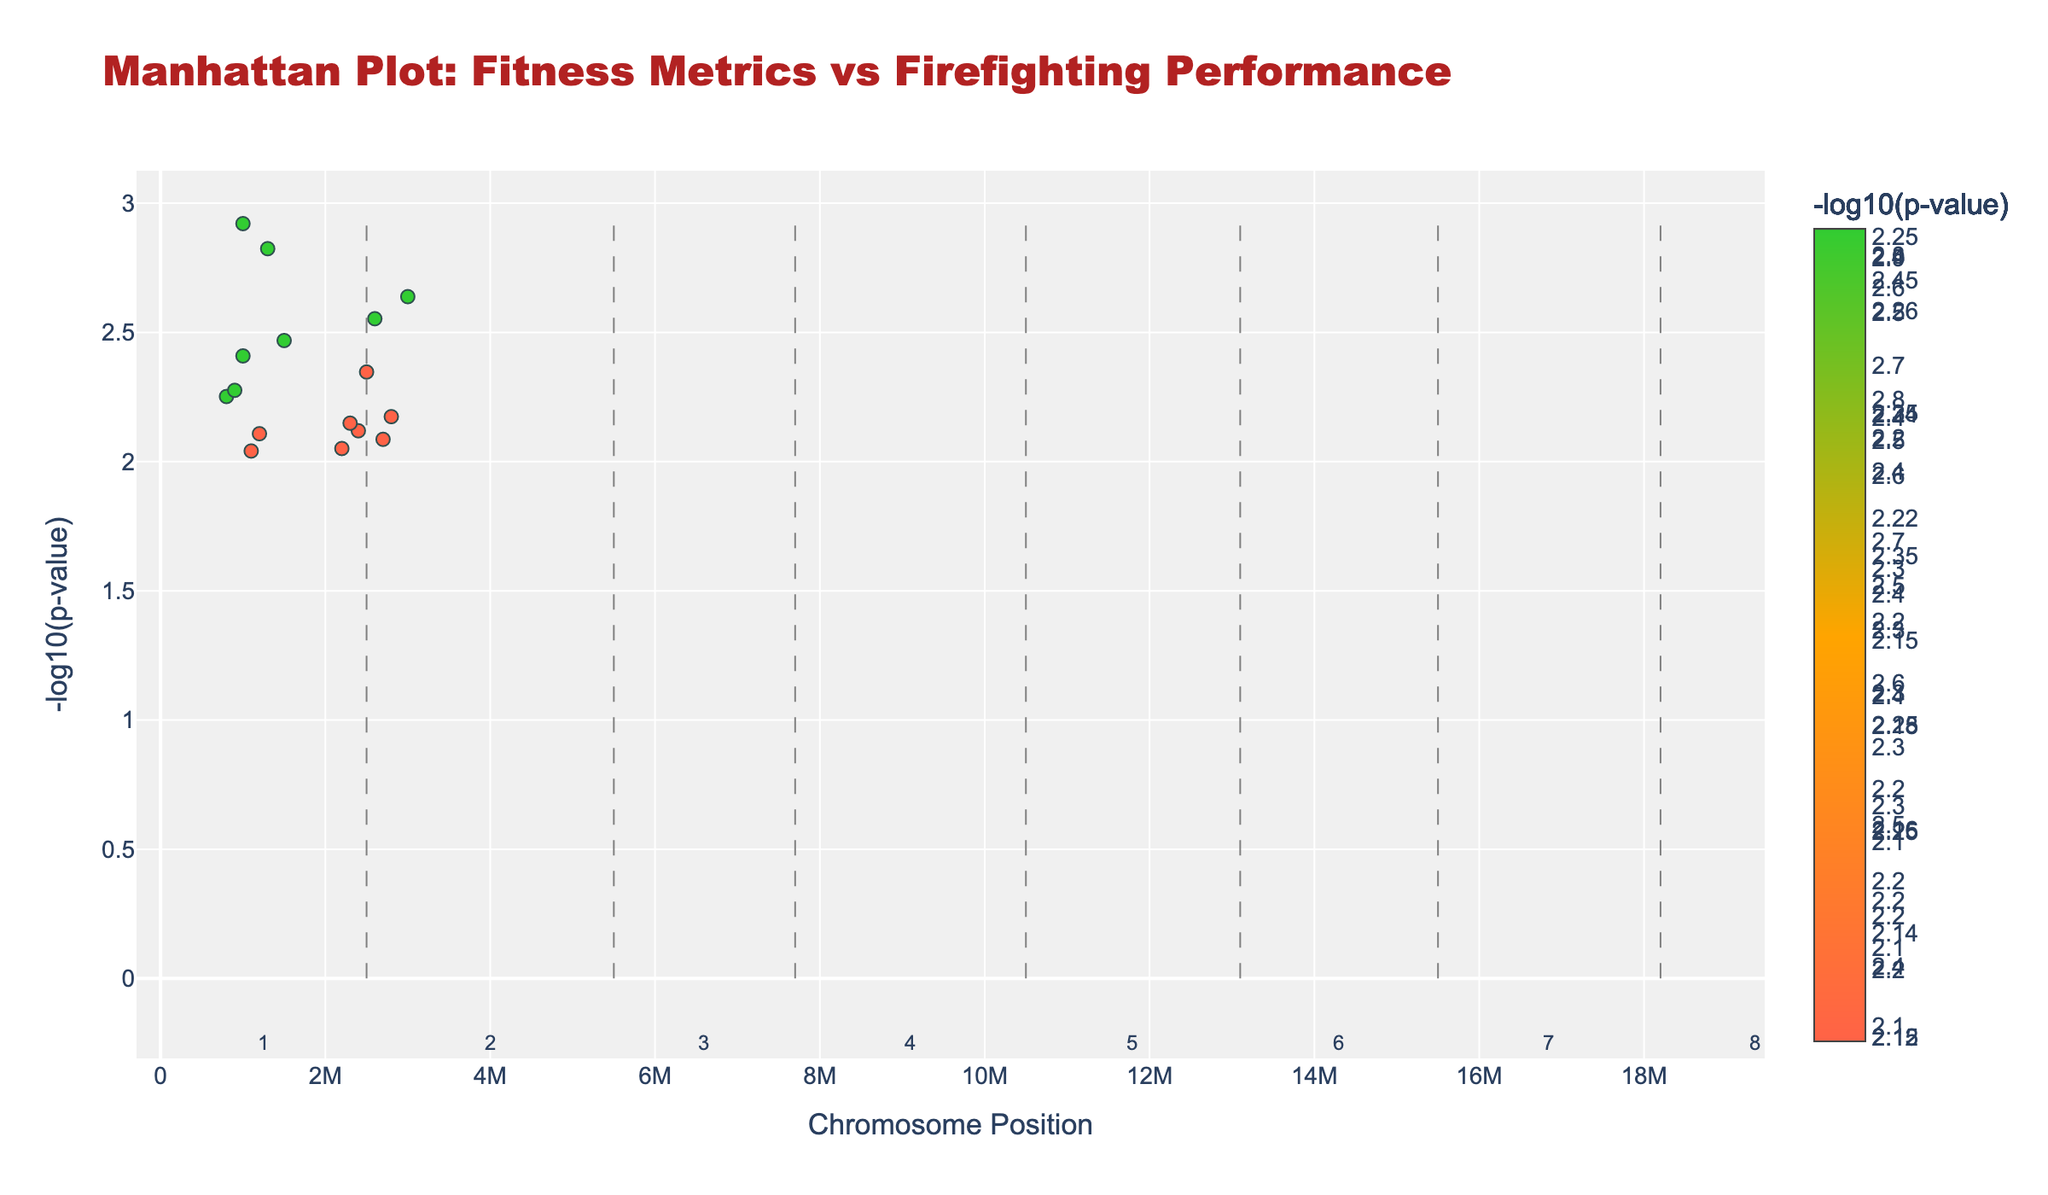What is the title of the plot? The title is displayed at the top of the plot in a larger and colorful font, which stands out.
Answer: Manhattan Plot: Fitness Metrics vs Firefighting Performance Which physical fitness metric has the lowest p-value? The physical fitness metric with the lowest p-value will have the highest -log10(p-value), represented by the tallest marker in the plot. By hovering over or checking the tallest marker, we see the metric associated with it.
Answer: VO2_max Between Chromosomes 4 and 6, which has the highest -log10(p-value) peak and what trait does it correspond to? By looking at the peaks for Chromosomes 4 and 6, we observe the vertical height of the markers. Chromosome 4 has a higher peak. Hovering over the marker for the highest peak reveals the associated trait.
Answer: Bench_press_1RM How many data points are plotted for Chromosome 7? Chromosome 7's data points can be counted by identifying the markers within the section labeled as Chromosome 7 on the plot; the chromosome section numbers are usually annotated at the bottom.
Answer: 2 What is the value range of -log10(p-value) for Chromosome 5? Looking at the vertical axis values that correspond to the markers for Chromosome 5, identify the lowest and highest -log10(p-value).
Answer: 2.04 to 2.55 Which trait is associated with the most significant data point on Chromosome 3? The most significant data point will have the highest -log10(p-value). Identify the tallest marker within the section for Chromosome 3 and hover over it for the trait information.
Answer: Body_fat_percentage Which Chromosome has the data point with the second-highest -log10(p-value)? First, determine the highest -log10(p-value) data point and identify its Chromosome. Then, find the next highest peak by comparing the rest and identify its Chromosome by hovering over the second tallest marker.
Answer: Chromosome 7 What is the difference in -log10(p-value) between the traits Ladder_climb_speed and Push_up_count? Find the -log10(p-value) for Ladder_climb_speed and Push_up_count by locating their markers and comparing the values displayed when hovering over them. Calculate the difference between these values.
Answer: 0.27 What trait on Chromosome 8 has the higher -log10(p-value)? Compare the heights of the markers for the two traits on Chromosome 8, Flexibility_score and Victim_rescue_simulation_time, and determine which trait's marker is taller.
Answer: Flexibility_score 